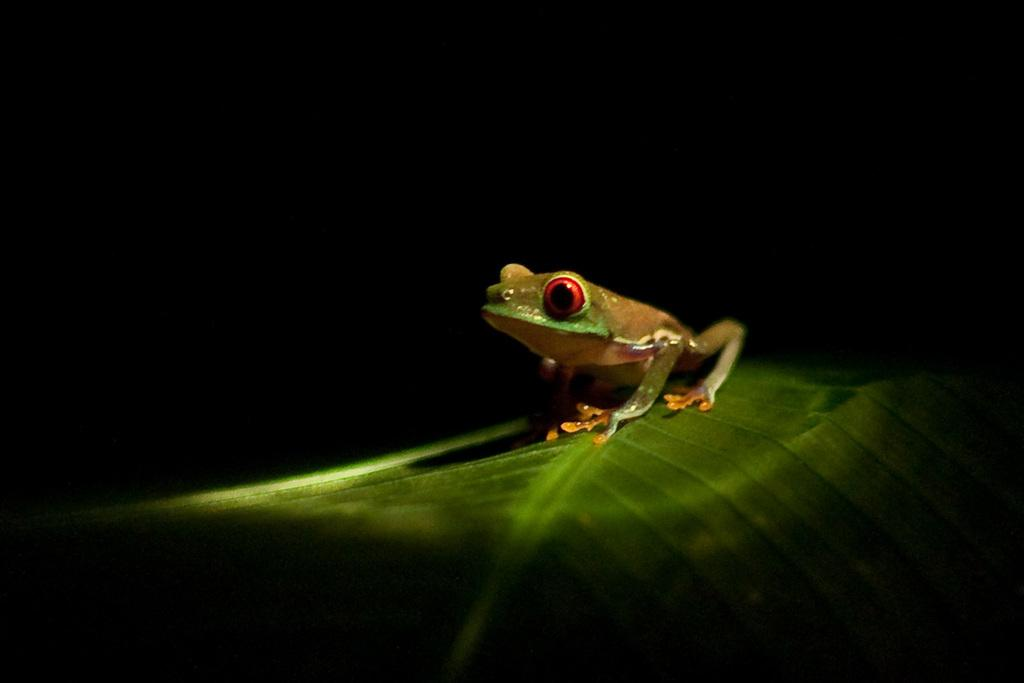What animal is present in the image? There is a frog in the image. Where is the frog located? The frog is on a green leaf. What can be observed about the background of the image? The background of the image is dark in color. What type of steel is used to construct the drain in the image? There is no drain present in the image, and therefore no steel can be observed. How many oranges are visible in the image? There are no oranges present in the image. 